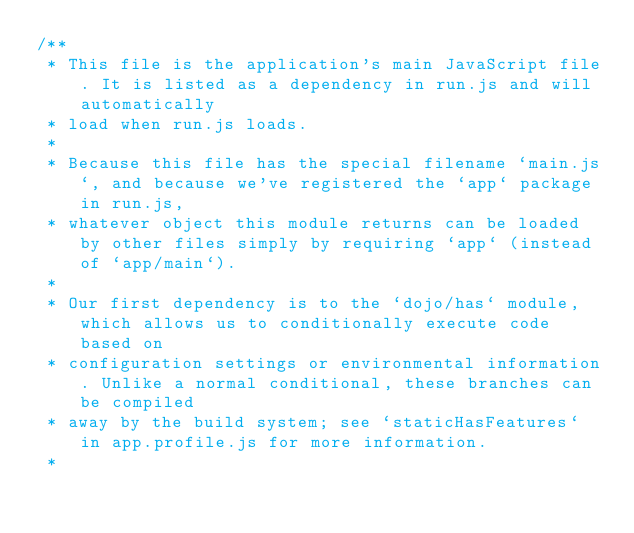Convert code to text. <code><loc_0><loc_0><loc_500><loc_500><_JavaScript_>/**
 * This file is the application's main JavaScript file. It is listed as a dependency in run.js and will automatically
 * load when run.js loads.
 *
 * Because this file has the special filename `main.js`, and because we've registered the `app` package in run.js,
 * whatever object this module returns can be loaded by other files simply by requiring `app` (instead of `app/main`).
 *
 * Our first dependency is to the `dojo/has` module, which allows us to conditionally execute code based on
 * configuration settings or environmental information. Unlike a normal conditional, these branches can be compiled
 * away by the build system; see `staticHasFeatures` in app.profile.js for more information.
 *</code> 